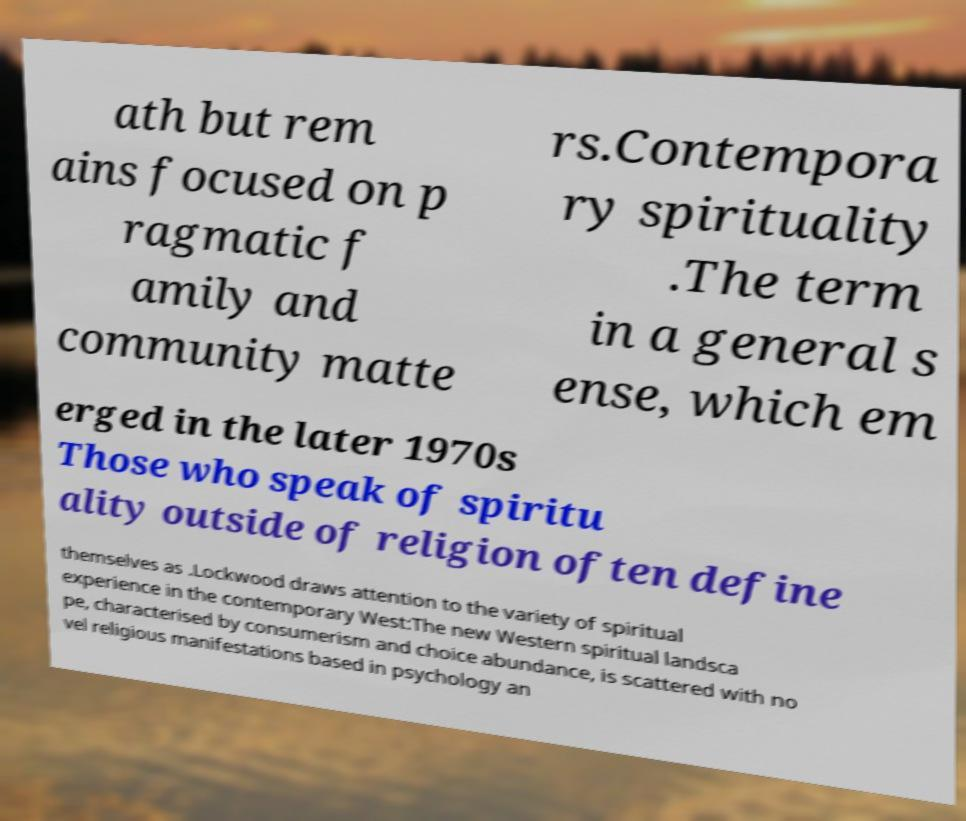Please identify and transcribe the text found in this image. ath but rem ains focused on p ragmatic f amily and community matte rs.Contempora ry spirituality .The term in a general s ense, which em erged in the later 1970s Those who speak of spiritu ality outside of religion often define themselves as .Lockwood draws attention to the variety of spiritual experience in the contemporary West:The new Western spiritual landsca pe, characterised by consumerism and choice abundance, is scattered with no vel religious manifestations based in psychology an 